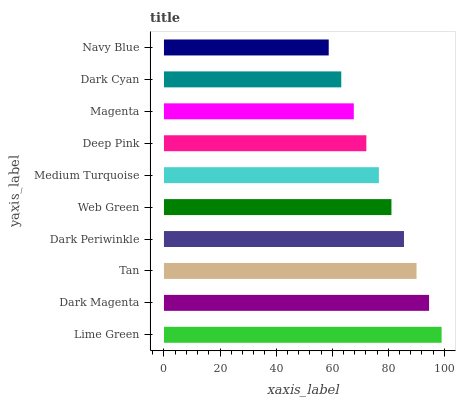Is Navy Blue the minimum?
Answer yes or no. Yes. Is Lime Green the maximum?
Answer yes or no. Yes. Is Dark Magenta the minimum?
Answer yes or no. No. Is Dark Magenta the maximum?
Answer yes or no. No. Is Lime Green greater than Dark Magenta?
Answer yes or no. Yes. Is Dark Magenta less than Lime Green?
Answer yes or no. Yes. Is Dark Magenta greater than Lime Green?
Answer yes or no. No. Is Lime Green less than Dark Magenta?
Answer yes or no. No. Is Web Green the high median?
Answer yes or no. Yes. Is Medium Turquoise the low median?
Answer yes or no. Yes. Is Tan the high median?
Answer yes or no. No. Is Web Green the low median?
Answer yes or no. No. 